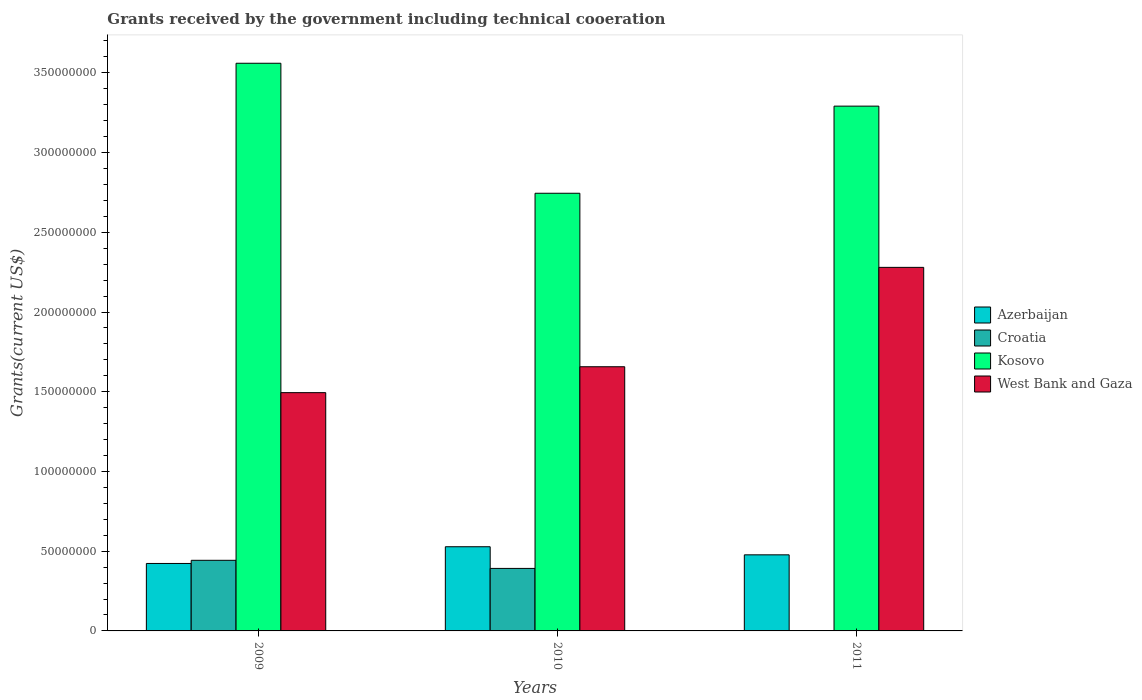How many bars are there on the 1st tick from the left?
Keep it short and to the point. 4. What is the label of the 2nd group of bars from the left?
Ensure brevity in your answer.  2010. In how many cases, is the number of bars for a given year not equal to the number of legend labels?
Make the answer very short. 0. What is the total grants received by the government in West Bank and Gaza in 2011?
Keep it short and to the point. 2.28e+08. Across all years, what is the maximum total grants received by the government in Azerbaijan?
Provide a short and direct response. 5.28e+07. Across all years, what is the minimum total grants received by the government in Azerbaijan?
Keep it short and to the point. 4.23e+07. In which year was the total grants received by the government in Azerbaijan maximum?
Ensure brevity in your answer.  2010. What is the total total grants received by the government in West Bank and Gaza in the graph?
Ensure brevity in your answer.  5.43e+08. What is the difference between the total grants received by the government in Kosovo in 2010 and that in 2011?
Ensure brevity in your answer.  -5.46e+07. What is the difference between the total grants received by the government in West Bank and Gaza in 2010 and the total grants received by the government in Kosovo in 2009?
Give a very brief answer. -1.90e+08. What is the average total grants received by the government in Croatia per year?
Give a very brief answer. 2.78e+07. In the year 2010, what is the difference between the total grants received by the government in Azerbaijan and total grants received by the government in Croatia?
Your response must be concise. 1.36e+07. In how many years, is the total grants received by the government in West Bank and Gaza greater than 260000000 US$?
Offer a very short reply. 0. What is the ratio of the total grants received by the government in Kosovo in 2009 to that in 2010?
Your answer should be compact. 1.3. Is the total grants received by the government in Azerbaijan in 2009 less than that in 2011?
Your answer should be compact. Yes. What is the difference between the highest and the second highest total grants received by the government in Croatia?
Give a very brief answer. 5.09e+06. What is the difference between the highest and the lowest total grants received by the government in West Bank and Gaza?
Make the answer very short. 7.86e+07. In how many years, is the total grants received by the government in Kosovo greater than the average total grants received by the government in Kosovo taken over all years?
Give a very brief answer. 2. Is the sum of the total grants received by the government in Croatia in 2010 and 2011 greater than the maximum total grants received by the government in West Bank and Gaza across all years?
Offer a very short reply. No. What does the 1st bar from the left in 2010 represents?
Your answer should be very brief. Azerbaijan. What does the 2nd bar from the right in 2009 represents?
Your answer should be very brief. Kosovo. Is it the case that in every year, the sum of the total grants received by the government in Croatia and total grants received by the government in Kosovo is greater than the total grants received by the government in West Bank and Gaza?
Your answer should be very brief. Yes. Are all the bars in the graph horizontal?
Ensure brevity in your answer.  No. What is the difference between two consecutive major ticks on the Y-axis?
Give a very brief answer. 5.00e+07. Are the values on the major ticks of Y-axis written in scientific E-notation?
Your response must be concise. No. Does the graph contain any zero values?
Your response must be concise. No. How are the legend labels stacked?
Provide a short and direct response. Vertical. What is the title of the graph?
Your response must be concise. Grants received by the government including technical cooeration. Does "Iran" appear as one of the legend labels in the graph?
Ensure brevity in your answer.  No. What is the label or title of the Y-axis?
Your response must be concise. Grants(current US$). What is the Grants(current US$) in Azerbaijan in 2009?
Provide a succinct answer. 4.23e+07. What is the Grants(current US$) of Croatia in 2009?
Offer a terse response. 4.43e+07. What is the Grants(current US$) in Kosovo in 2009?
Offer a very short reply. 3.56e+08. What is the Grants(current US$) in West Bank and Gaza in 2009?
Your answer should be compact. 1.49e+08. What is the Grants(current US$) of Azerbaijan in 2010?
Your answer should be very brief. 5.28e+07. What is the Grants(current US$) in Croatia in 2010?
Keep it short and to the point. 3.92e+07. What is the Grants(current US$) in Kosovo in 2010?
Provide a short and direct response. 2.74e+08. What is the Grants(current US$) in West Bank and Gaza in 2010?
Your answer should be compact. 1.66e+08. What is the Grants(current US$) in Azerbaijan in 2011?
Provide a succinct answer. 4.77e+07. What is the Grants(current US$) of Croatia in 2011?
Your answer should be compact. 2.00e+04. What is the Grants(current US$) in Kosovo in 2011?
Ensure brevity in your answer.  3.29e+08. What is the Grants(current US$) in West Bank and Gaza in 2011?
Ensure brevity in your answer.  2.28e+08. Across all years, what is the maximum Grants(current US$) in Azerbaijan?
Offer a very short reply. 5.28e+07. Across all years, what is the maximum Grants(current US$) of Croatia?
Keep it short and to the point. 4.43e+07. Across all years, what is the maximum Grants(current US$) in Kosovo?
Ensure brevity in your answer.  3.56e+08. Across all years, what is the maximum Grants(current US$) of West Bank and Gaza?
Offer a very short reply. 2.28e+08. Across all years, what is the minimum Grants(current US$) of Azerbaijan?
Your answer should be compact. 4.23e+07. Across all years, what is the minimum Grants(current US$) of Kosovo?
Your response must be concise. 2.74e+08. Across all years, what is the minimum Grants(current US$) of West Bank and Gaza?
Make the answer very short. 1.49e+08. What is the total Grants(current US$) in Azerbaijan in the graph?
Your answer should be very brief. 1.43e+08. What is the total Grants(current US$) of Croatia in the graph?
Provide a succinct answer. 8.35e+07. What is the total Grants(current US$) of Kosovo in the graph?
Give a very brief answer. 9.60e+08. What is the total Grants(current US$) of West Bank and Gaza in the graph?
Your answer should be very brief. 5.43e+08. What is the difference between the Grants(current US$) of Azerbaijan in 2009 and that in 2010?
Ensure brevity in your answer.  -1.05e+07. What is the difference between the Grants(current US$) of Croatia in 2009 and that in 2010?
Provide a succinct answer. 5.09e+06. What is the difference between the Grants(current US$) in Kosovo in 2009 and that in 2010?
Keep it short and to the point. 8.15e+07. What is the difference between the Grants(current US$) in West Bank and Gaza in 2009 and that in 2010?
Ensure brevity in your answer.  -1.62e+07. What is the difference between the Grants(current US$) in Azerbaijan in 2009 and that in 2011?
Offer a terse response. -5.41e+06. What is the difference between the Grants(current US$) in Croatia in 2009 and that in 2011?
Offer a very short reply. 4.43e+07. What is the difference between the Grants(current US$) of Kosovo in 2009 and that in 2011?
Give a very brief answer. 2.69e+07. What is the difference between the Grants(current US$) of West Bank and Gaza in 2009 and that in 2011?
Offer a very short reply. -7.86e+07. What is the difference between the Grants(current US$) of Azerbaijan in 2010 and that in 2011?
Provide a short and direct response. 5.08e+06. What is the difference between the Grants(current US$) in Croatia in 2010 and that in 2011?
Provide a succinct answer. 3.92e+07. What is the difference between the Grants(current US$) of Kosovo in 2010 and that in 2011?
Your answer should be compact. -5.46e+07. What is the difference between the Grants(current US$) in West Bank and Gaza in 2010 and that in 2011?
Keep it short and to the point. -6.23e+07. What is the difference between the Grants(current US$) of Azerbaijan in 2009 and the Grants(current US$) of Croatia in 2010?
Give a very brief answer. 3.11e+06. What is the difference between the Grants(current US$) in Azerbaijan in 2009 and the Grants(current US$) in Kosovo in 2010?
Make the answer very short. -2.32e+08. What is the difference between the Grants(current US$) in Azerbaijan in 2009 and the Grants(current US$) in West Bank and Gaza in 2010?
Ensure brevity in your answer.  -1.23e+08. What is the difference between the Grants(current US$) of Croatia in 2009 and the Grants(current US$) of Kosovo in 2010?
Keep it short and to the point. -2.30e+08. What is the difference between the Grants(current US$) in Croatia in 2009 and the Grants(current US$) in West Bank and Gaza in 2010?
Offer a very short reply. -1.21e+08. What is the difference between the Grants(current US$) of Kosovo in 2009 and the Grants(current US$) of West Bank and Gaza in 2010?
Offer a very short reply. 1.90e+08. What is the difference between the Grants(current US$) of Azerbaijan in 2009 and the Grants(current US$) of Croatia in 2011?
Your answer should be very brief. 4.23e+07. What is the difference between the Grants(current US$) in Azerbaijan in 2009 and the Grants(current US$) in Kosovo in 2011?
Keep it short and to the point. -2.87e+08. What is the difference between the Grants(current US$) in Azerbaijan in 2009 and the Grants(current US$) in West Bank and Gaza in 2011?
Your answer should be compact. -1.86e+08. What is the difference between the Grants(current US$) of Croatia in 2009 and the Grants(current US$) of Kosovo in 2011?
Keep it short and to the point. -2.85e+08. What is the difference between the Grants(current US$) of Croatia in 2009 and the Grants(current US$) of West Bank and Gaza in 2011?
Provide a succinct answer. -1.84e+08. What is the difference between the Grants(current US$) of Kosovo in 2009 and the Grants(current US$) of West Bank and Gaza in 2011?
Give a very brief answer. 1.28e+08. What is the difference between the Grants(current US$) in Azerbaijan in 2010 and the Grants(current US$) in Croatia in 2011?
Offer a terse response. 5.28e+07. What is the difference between the Grants(current US$) of Azerbaijan in 2010 and the Grants(current US$) of Kosovo in 2011?
Offer a terse response. -2.76e+08. What is the difference between the Grants(current US$) of Azerbaijan in 2010 and the Grants(current US$) of West Bank and Gaza in 2011?
Your answer should be compact. -1.75e+08. What is the difference between the Grants(current US$) in Croatia in 2010 and the Grants(current US$) in Kosovo in 2011?
Ensure brevity in your answer.  -2.90e+08. What is the difference between the Grants(current US$) in Croatia in 2010 and the Grants(current US$) in West Bank and Gaza in 2011?
Provide a succinct answer. -1.89e+08. What is the difference between the Grants(current US$) in Kosovo in 2010 and the Grants(current US$) in West Bank and Gaza in 2011?
Your answer should be very brief. 4.65e+07. What is the average Grants(current US$) in Azerbaijan per year?
Your response must be concise. 4.76e+07. What is the average Grants(current US$) in Croatia per year?
Your answer should be very brief. 2.78e+07. What is the average Grants(current US$) of Kosovo per year?
Your answer should be compact. 3.20e+08. What is the average Grants(current US$) of West Bank and Gaza per year?
Keep it short and to the point. 1.81e+08. In the year 2009, what is the difference between the Grants(current US$) in Azerbaijan and Grants(current US$) in Croatia?
Your answer should be very brief. -1.98e+06. In the year 2009, what is the difference between the Grants(current US$) of Azerbaijan and Grants(current US$) of Kosovo?
Provide a succinct answer. -3.14e+08. In the year 2009, what is the difference between the Grants(current US$) in Azerbaijan and Grants(current US$) in West Bank and Gaza?
Offer a very short reply. -1.07e+08. In the year 2009, what is the difference between the Grants(current US$) in Croatia and Grants(current US$) in Kosovo?
Make the answer very short. -3.12e+08. In the year 2009, what is the difference between the Grants(current US$) of Croatia and Grants(current US$) of West Bank and Gaza?
Provide a succinct answer. -1.05e+08. In the year 2009, what is the difference between the Grants(current US$) of Kosovo and Grants(current US$) of West Bank and Gaza?
Offer a terse response. 2.07e+08. In the year 2010, what is the difference between the Grants(current US$) in Azerbaijan and Grants(current US$) in Croatia?
Provide a short and direct response. 1.36e+07. In the year 2010, what is the difference between the Grants(current US$) in Azerbaijan and Grants(current US$) in Kosovo?
Give a very brief answer. -2.22e+08. In the year 2010, what is the difference between the Grants(current US$) in Azerbaijan and Grants(current US$) in West Bank and Gaza?
Your response must be concise. -1.13e+08. In the year 2010, what is the difference between the Grants(current US$) in Croatia and Grants(current US$) in Kosovo?
Offer a very short reply. -2.35e+08. In the year 2010, what is the difference between the Grants(current US$) of Croatia and Grants(current US$) of West Bank and Gaza?
Keep it short and to the point. -1.26e+08. In the year 2010, what is the difference between the Grants(current US$) of Kosovo and Grants(current US$) of West Bank and Gaza?
Provide a short and direct response. 1.09e+08. In the year 2011, what is the difference between the Grants(current US$) of Azerbaijan and Grants(current US$) of Croatia?
Your response must be concise. 4.77e+07. In the year 2011, what is the difference between the Grants(current US$) in Azerbaijan and Grants(current US$) in Kosovo?
Your answer should be very brief. -2.81e+08. In the year 2011, what is the difference between the Grants(current US$) of Azerbaijan and Grants(current US$) of West Bank and Gaza?
Your answer should be compact. -1.80e+08. In the year 2011, what is the difference between the Grants(current US$) of Croatia and Grants(current US$) of Kosovo?
Offer a very short reply. -3.29e+08. In the year 2011, what is the difference between the Grants(current US$) in Croatia and Grants(current US$) in West Bank and Gaza?
Ensure brevity in your answer.  -2.28e+08. In the year 2011, what is the difference between the Grants(current US$) of Kosovo and Grants(current US$) of West Bank and Gaza?
Give a very brief answer. 1.01e+08. What is the ratio of the Grants(current US$) of Azerbaijan in 2009 to that in 2010?
Your response must be concise. 0.8. What is the ratio of the Grants(current US$) in Croatia in 2009 to that in 2010?
Provide a succinct answer. 1.13. What is the ratio of the Grants(current US$) of Kosovo in 2009 to that in 2010?
Your answer should be compact. 1.3. What is the ratio of the Grants(current US$) of West Bank and Gaza in 2009 to that in 2010?
Your answer should be very brief. 0.9. What is the ratio of the Grants(current US$) of Azerbaijan in 2009 to that in 2011?
Keep it short and to the point. 0.89. What is the ratio of the Grants(current US$) of Croatia in 2009 to that in 2011?
Your response must be concise. 2214.5. What is the ratio of the Grants(current US$) in Kosovo in 2009 to that in 2011?
Provide a succinct answer. 1.08. What is the ratio of the Grants(current US$) in West Bank and Gaza in 2009 to that in 2011?
Your answer should be compact. 0.66. What is the ratio of the Grants(current US$) of Azerbaijan in 2010 to that in 2011?
Make the answer very short. 1.11. What is the ratio of the Grants(current US$) of Croatia in 2010 to that in 2011?
Provide a succinct answer. 1960. What is the ratio of the Grants(current US$) in Kosovo in 2010 to that in 2011?
Offer a terse response. 0.83. What is the ratio of the Grants(current US$) of West Bank and Gaza in 2010 to that in 2011?
Your answer should be compact. 0.73. What is the difference between the highest and the second highest Grants(current US$) of Azerbaijan?
Provide a succinct answer. 5.08e+06. What is the difference between the highest and the second highest Grants(current US$) in Croatia?
Provide a succinct answer. 5.09e+06. What is the difference between the highest and the second highest Grants(current US$) in Kosovo?
Your answer should be compact. 2.69e+07. What is the difference between the highest and the second highest Grants(current US$) in West Bank and Gaza?
Provide a short and direct response. 6.23e+07. What is the difference between the highest and the lowest Grants(current US$) in Azerbaijan?
Offer a terse response. 1.05e+07. What is the difference between the highest and the lowest Grants(current US$) in Croatia?
Make the answer very short. 4.43e+07. What is the difference between the highest and the lowest Grants(current US$) of Kosovo?
Give a very brief answer. 8.15e+07. What is the difference between the highest and the lowest Grants(current US$) of West Bank and Gaza?
Offer a terse response. 7.86e+07. 